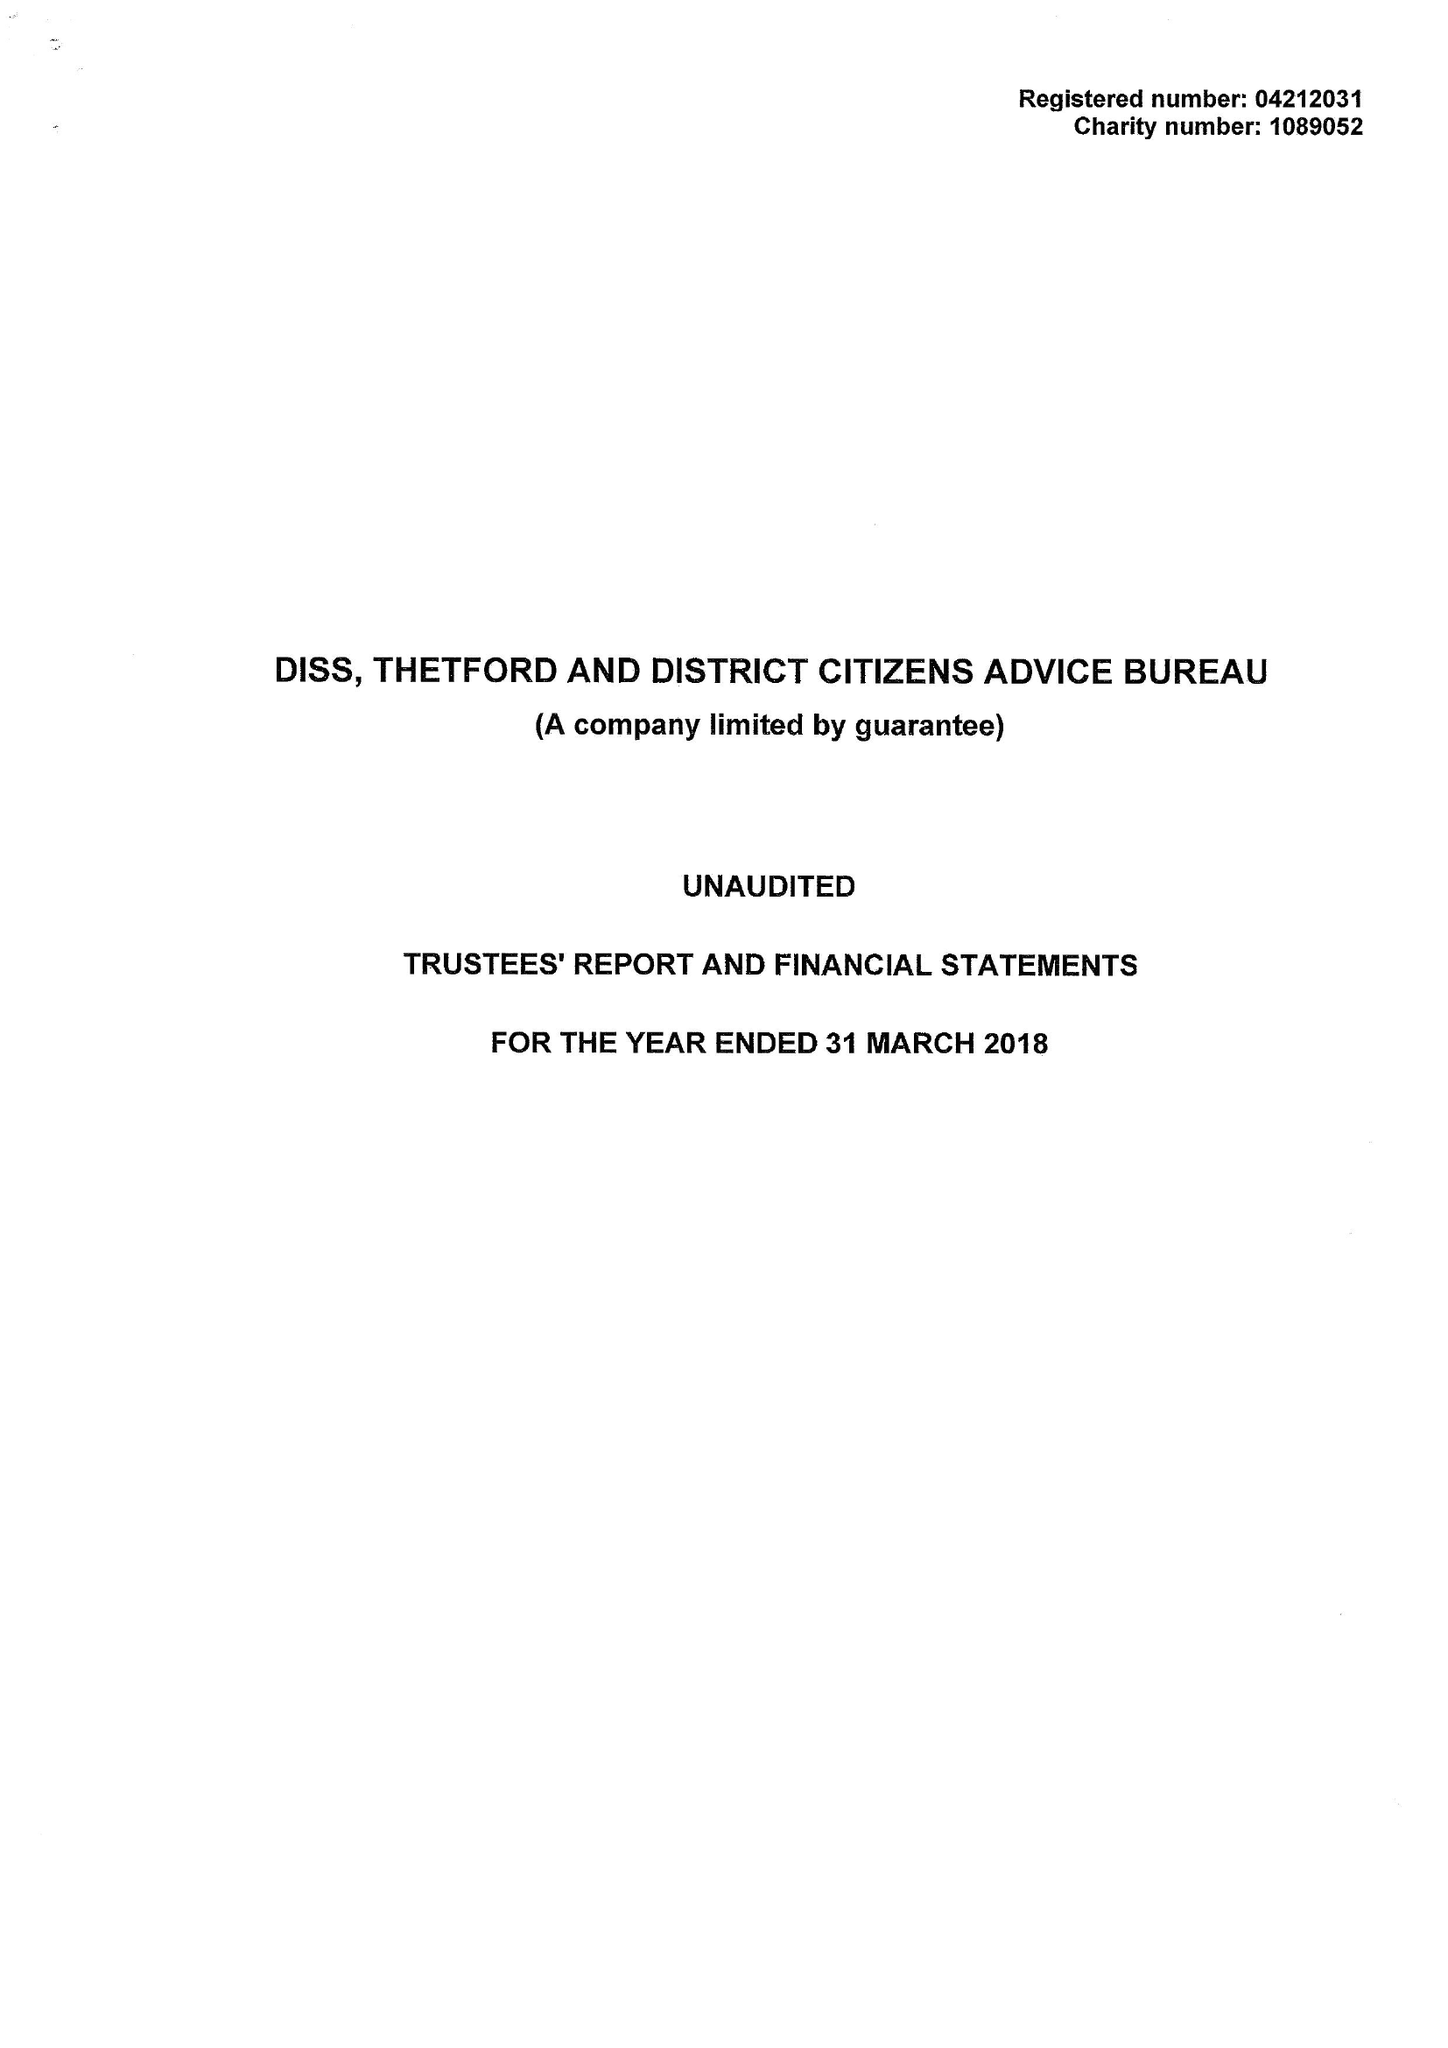What is the value for the address__postcode?
Answer the question using a single word or phrase. IP22 4EH 